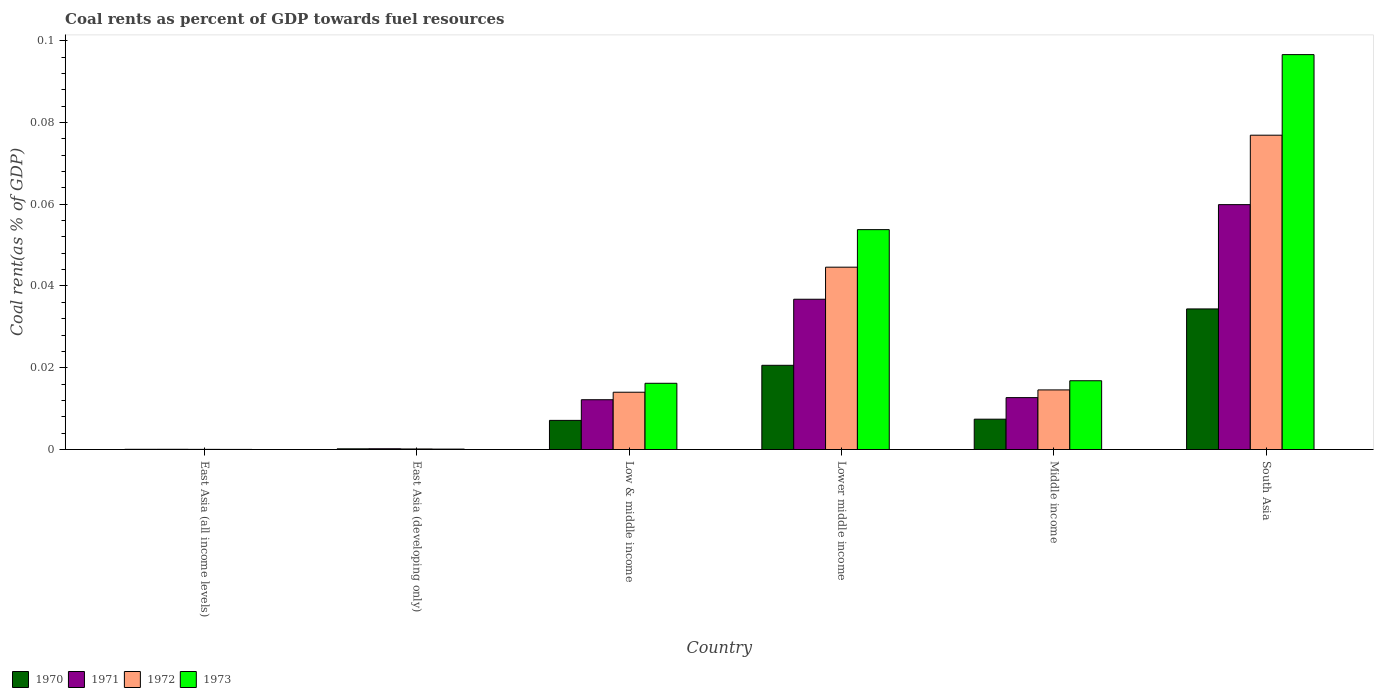How many groups of bars are there?
Provide a short and direct response. 6. Are the number of bars per tick equal to the number of legend labels?
Ensure brevity in your answer.  Yes. What is the label of the 6th group of bars from the left?
Your response must be concise. South Asia. In how many cases, is the number of bars for a given country not equal to the number of legend labels?
Keep it short and to the point. 0. What is the coal rent in 1973 in East Asia (all income levels)?
Make the answer very short. 2.64171247686014e-5. Across all countries, what is the maximum coal rent in 1971?
Your response must be concise. 0.06. Across all countries, what is the minimum coal rent in 1972?
Provide a succinct answer. 3.67730514806032e-5. In which country was the coal rent in 1972 minimum?
Provide a succinct answer. East Asia (all income levels). What is the total coal rent in 1970 in the graph?
Give a very brief answer. 0.07. What is the difference between the coal rent in 1970 in East Asia (all income levels) and that in Lower middle income?
Make the answer very short. -0.02. What is the difference between the coal rent in 1973 in Low & middle income and the coal rent in 1971 in Middle income?
Provide a short and direct response. 0. What is the average coal rent in 1971 per country?
Ensure brevity in your answer.  0.02. What is the difference between the coal rent of/in 1973 and coal rent of/in 1971 in Lower middle income?
Your answer should be very brief. 0.02. In how many countries, is the coal rent in 1972 greater than 0.08 %?
Give a very brief answer. 0. What is the ratio of the coal rent in 1971 in East Asia (all income levels) to that in Lower middle income?
Offer a terse response. 0. Is the coal rent in 1970 in Middle income less than that in South Asia?
Provide a short and direct response. Yes. What is the difference between the highest and the second highest coal rent in 1972?
Ensure brevity in your answer.  0.03. What is the difference between the highest and the lowest coal rent in 1971?
Ensure brevity in your answer.  0.06. Is the sum of the coal rent in 1973 in East Asia (developing only) and South Asia greater than the maximum coal rent in 1971 across all countries?
Provide a succinct answer. Yes. Are the values on the major ticks of Y-axis written in scientific E-notation?
Offer a terse response. No. Does the graph contain any zero values?
Provide a succinct answer. No. Where does the legend appear in the graph?
Offer a very short reply. Bottom left. How are the legend labels stacked?
Offer a terse response. Horizontal. What is the title of the graph?
Provide a succinct answer. Coal rents as percent of GDP towards fuel resources. Does "2001" appear as one of the legend labels in the graph?
Give a very brief answer. No. What is the label or title of the X-axis?
Your answer should be very brief. Country. What is the label or title of the Y-axis?
Make the answer very short. Coal rent(as % of GDP). What is the Coal rent(as % of GDP) of 1970 in East Asia (all income levels)?
Make the answer very short. 5.1314079013758e-5. What is the Coal rent(as % of GDP) of 1971 in East Asia (all income levels)?
Your answer should be very brief. 5.470114168356261e-5. What is the Coal rent(as % of GDP) of 1972 in East Asia (all income levels)?
Give a very brief answer. 3.67730514806032e-5. What is the Coal rent(as % of GDP) in 1973 in East Asia (all income levels)?
Give a very brief answer. 2.64171247686014e-5. What is the Coal rent(as % of GDP) in 1970 in East Asia (developing only)?
Your answer should be very brief. 0. What is the Coal rent(as % of GDP) of 1971 in East Asia (developing only)?
Offer a terse response. 0. What is the Coal rent(as % of GDP) in 1972 in East Asia (developing only)?
Keep it short and to the point. 0. What is the Coal rent(as % of GDP) of 1973 in East Asia (developing only)?
Your response must be concise. 0. What is the Coal rent(as % of GDP) of 1970 in Low & middle income?
Your response must be concise. 0.01. What is the Coal rent(as % of GDP) in 1971 in Low & middle income?
Offer a terse response. 0.01. What is the Coal rent(as % of GDP) in 1972 in Low & middle income?
Make the answer very short. 0.01. What is the Coal rent(as % of GDP) in 1973 in Low & middle income?
Make the answer very short. 0.02. What is the Coal rent(as % of GDP) of 1970 in Lower middle income?
Offer a very short reply. 0.02. What is the Coal rent(as % of GDP) of 1971 in Lower middle income?
Your response must be concise. 0.04. What is the Coal rent(as % of GDP) in 1972 in Lower middle income?
Make the answer very short. 0.04. What is the Coal rent(as % of GDP) in 1973 in Lower middle income?
Your answer should be very brief. 0.05. What is the Coal rent(as % of GDP) in 1970 in Middle income?
Keep it short and to the point. 0.01. What is the Coal rent(as % of GDP) of 1971 in Middle income?
Your response must be concise. 0.01. What is the Coal rent(as % of GDP) in 1972 in Middle income?
Provide a short and direct response. 0.01. What is the Coal rent(as % of GDP) of 1973 in Middle income?
Provide a short and direct response. 0.02. What is the Coal rent(as % of GDP) in 1970 in South Asia?
Provide a short and direct response. 0.03. What is the Coal rent(as % of GDP) in 1971 in South Asia?
Your response must be concise. 0.06. What is the Coal rent(as % of GDP) of 1972 in South Asia?
Give a very brief answer. 0.08. What is the Coal rent(as % of GDP) of 1973 in South Asia?
Give a very brief answer. 0.1. Across all countries, what is the maximum Coal rent(as % of GDP) of 1970?
Your answer should be compact. 0.03. Across all countries, what is the maximum Coal rent(as % of GDP) in 1971?
Your response must be concise. 0.06. Across all countries, what is the maximum Coal rent(as % of GDP) of 1972?
Offer a very short reply. 0.08. Across all countries, what is the maximum Coal rent(as % of GDP) in 1973?
Provide a short and direct response. 0.1. Across all countries, what is the minimum Coal rent(as % of GDP) in 1970?
Your answer should be compact. 5.1314079013758e-5. Across all countries, what is the minimum Coal rent(as % of GDP) of 1971?
Your answer should be very brief. 5.470114168356261e-5. Across all countries, what is the minimum Coal rent(as % of GDP) in 1972?
Give a very brief answer. 3.67730514806032e-5. Across all countries, what is the minimum Coal rent(as % of GDP) in 1973?
Ensure brevity in your answer.  2.64171247686014e-5. What is the total Coal rent(as % of GDP) of 1970 in the graph?
Provide a short and direct response. 0.07. What is the total Coal rent(as % of GDP) of 1971 in the graph?
Offer a very short reply. 0.12. What is the total Coal rent(as % of GDP) of 1972 in the graph?
Offer a very short reply. 0.15. What is the total Coal rent(as % of GDP) in 1973 in the graph?
Offer a very short reply. 0.18. What is the difference between the Coal rent(as % of GDP) of 1970 in East Asia (all income levels) and that in East Asia (developing only)?
Provide a succinct answer. -0. What is the difference between the Coal rent(as % of GDP) of 1971 in East Asia (all income levels) and that in East Asia (developing only)?
Offer a very short reply. -0. What is the difference between the Coal rent(as % of GDP) of 1972 in East Asia (all income levels) and that in East Asia (developing only)?
Offer a very short reply. -0. What is the difference between the Coal rent(as % of GDP) in 1973 in East Asia (all income levels) and that in East Asia (developing only)?
Provide a succinct answer. -0. What is the difference between the Coal rent(as % of GDP) in 1970 in East Asia (all income levels) and that in Low & middle income?
Provide a short and direct response. -0.01. What is the difference between the Coal rent(as % of GDP) in 1971 in East Asia (all income levels) and that in Low & middle income?
Your answer should be compact. -0.01. What is the difference between the Coal rent(as % of GDP) in 1972 in East Asia (all income levels) and that in Low & middle income?
Make the answer very short. -0.01. What is the difference between the Coal rent(as % of GDP) in 1973 in East Asia (all income levels) and that in Low & middle income?
Your answer should be very brief. -0.02. What is the difference between the Coal rent(as % of GDP) in 1970 in East Asia (all income levels) and that in Lower middle income?
Your answer should be compact. -0.02. What is the difference between the Coal rent(as % of GDP) in 1971 in East Asia (all income levels) and that in Lower middle income?
Offer a very short reply. -0.04. What is the difference between the Coal rent(as % of GDP) in 1972 in East Asia (all income levels) and that in Lower middle income?
Keep it short and to the point. -0.04. What is the difference between the Coal rent(as % of GDP) in 1973 in East Asia (all income levels) and that in Lower middle income?
Give a very brief answer. -0.05. What is the difference between the Coal rent(as % of GDP) in 1970 in East Asia (all income levels) and that in Middle income?
Your answer should be compact. -0.01. What is the difference between the Coal rent(as % of GDP) in 1971 in East Asia (all income levels) and that in Middle income?
Offer a very short reply. -0.01. What is the difference between the Coal rent(as % of GDP) of 1972 in East Asia (all income levels) and that in Middle income?
Provide a short and direct response. -0.01. What is the difference between the Coal rent(as % of GDP) in 1973 in East Asia (all income levels) and that in Middle income?
Keep it short and to the point. -0.02. What is the difference between the Coal rent(as % of GDP) in 1970 in East Asia (all income levels) and that in South Asia?
Offer a terse response. -0.03. What is the difference between the Coal rent(as % of GDP) in 1971 in East Asia (all income levels) and that in South Asia?
Your answer should be compact. -0.06. What is the difference between the Coal rent(as % of GDP) of 1972 in East Asia (all income levels) and that in South Asia?
Offer a terse response. -0.08. What is the difference between the Coal rent(as % of GDP) in 1973 in East Asia (all income levels) and that in South Asia?
Provide a short and direct response. -0.1. What is the difference between the Coal rent(as % of GDP) of 1970 in East Asia (developing only) and that in Low & middle income?
Offer a terse response. -0.01. What is the difference between the Coal rent(as % of GDP) in 1971 in East Asia (developing only) and that in Low & middle income?
Ensure brevity in your answer.  -0.01. What is the difference between the Coal rent(as % of GDP) in 1972 in East Asia (developing only) and that in Low & middle income?
Provide a short and direct response. -0.01. What is the difference between the Coal rent(as % of GDP) of 1973 in East Asia (developing only) and that in Low & middle income?
Offer a very short reply. -0.02. What is the difference between the Coal rent(as % of GDP) in 1970 in East Asia (developing only) and that in Lower middle income?
Your answer should be very brief. -0.02. What is the difference between the Coal rent(as % of GDP) of 1971 in East Asia (developing only) and that in Lower middle income?
Your answer should be compact. -0.04. What is the difference between the Coal rent(as % of GDP) in 1972 in East Asia (developing only) and that in Lower middle income?
Your response must be concise. -0.04. What is the difference between the Coal rent(as % of GDP) of 1973 in East Asia (developing only) and that in Lower middle income?
Offer a terse response. -0.05. What is the difference between the Coal rent(as % of GDP) of 1970 in East Asia (developing only) and that in Middle income?
Give a very brief answer. -0.01. What is the difference between the Coal rent(as % of GDP) of 1971 in East Asia (developing only) and that in Middle income?
Give a very brief answer. -0.01. What is the difference between the Coal rent(as % of GDP) in 1972 in East Asia (developing only) and that in Middle income?
Keep it short and to the point. -0.01. What is the difference between the Coal rent(as % of GDP) in 1973 in East Asia (developing only) and that in Middle income?
Make the answer very short. -0.02. What is the difference between the Coal rent(as % of GDP) of 1970 in East Asia (developing only) and that in South Asia?
Provide a short and direct response. -0.03. What is the difference between the Coal rent(as % of GDP) of 1971 in East Asia (developing only) and that in South Asia?
Offer a terse response. -0.06. What is the difference between the Coal rent(as % of GDP) in 1972 in East Asia (developing only) and that in South Asia?
Offer a terse response. -0.08. What is the difference between the Coal rent(as % of GDP) in 1973 in East Asia (developing only) and that in South Asia?
Offer a very short reply. -0.1. What is the difference between the Coal rent(as % of GDP) in 1970 in Low & middle income and that in Lower middle income?
Provide a short and direct response. -0.01. What is the difference between the Coal rent(as % of GDP) in 1971 in Low & middle income and that in Lower middle income?
Make the answer very short. -0.02. What is the difference between the Coal rent(as % of GDP) in 1972 in Low & middle income and that in Lower middle income?
Make the answer very short. -0.03. What is the difference between the Coal rent(as % of GDP) of 1973 in Low & middle income and that in Lower middle income?
Provide a short and direct response. -0.04. What is the difference between the Coal rent(as % of GDP) of 1970 in Low & middle income and that in Middle income?
Make the answer very short. -0. What is the difference between the Coal rent(as % of GDP) in 1971 in Low & middle income and that in Middle income?
Give a very brief answer. -0. What is the difference between the Coal rent(as % of GDP) of 1972 in Low & middle income and that in Middle income?
Your response must be concise. -0. What is the difference between the Coal rent(as % of GDP) of 1973 in Low & middle income and that in Middle income?
Offer a very short reply. -0. What is the difference between the Coal rent(as % of GDP) of 1970 in Low & middle income and that in South Asia?
Ensure brevity in your answer.  -0.03. What is the difference between the Coal rent(as % of GDP) of 1971 in Low & middle income and that in South Asia?
Give a very brief answer. -0.05. What is the difference between the Coal rent(as % of GDP) in 1972 in Low & middle income and that in South Asia?
Provide a succinct answer. -0.06. What is the difference between the Coal rent(as % of GDP) of 1973 in Low & middle income and that in South Asia?
Keep it short and to the point. -0.08. What is the difference between the Coal rent(as % of GDP) of 1970 in Lower middle income and that in Middle income?
Give a very brief answer. 0.01. What is the difference between the Coal rent(as % of GDP) of 1971 in Lower middle income and that in Middle income?
Make the answer very short. 0.02. What is the difference between the Coal rent(as % of GDP) of 1973 in Lower middle income and that in Middle income?
Your response must be concise. 0.04. What is the difference between the Coal rent(as % of GDP) of 1970 in Lower middle income and that in South Asia?
Your response must be concise. -0.01. What is the difference between the Coal rent(as % of GDP) in 1971 in Lower middle income and that in South Asia?
Offer a terse response. -0.02. What is the difference between the Coal rent(as % of GDP) of 1972 in Lower middle income and that in South Asia?
Give a very brief answer. -0.03. What is the difference between the Coal rent(as % of GDP) of 1973 in Lower middle income and that in South Asia?
Your answer should be compact. -0.04. What is the difference between the Coal rent(as % of GDP) in 1970 in Middle income and that in South Asia?
Offer a very short reply. -0.03. What is the difference between the Coal rent(as % of GDP) of 1971 in Middle income and that in South Asia?
Your answer should be very brief. -0.05. What is the difference between the Coal rent(as % of GDP) of 1972 in Middle income and that in South Asia?
Keep it short and to the point. -0.06. What is the difference between the Coal rent(as % of GDP) in 1973 in Middle income and that in South Asia?
Provide a short and direct response. -0.08. What is the difference between the Coal rent(as % of GDP) of 1970 in East Asia (all income levels) and the Coal rent(as % of GDP) of 1971 in East Asia (developing only)?
Your answer should be compact. -0. What is the difference between the Coal rent(as % of GDP) of 1970 in East Asia (all income levels) and the Coal rent(as % of GDP) of 1972 in East Asia (developing only)?
Give a very brief answer. -0. What is the difference between the Coal rent(as % of GDP) in 1970 in East Asia (all income levels) and the Coal rent(as % of GDP) in 1973 in East Asia (developing only)?
Your answer should be very brief. -0. What is the difference between the Coal rent(as % of GDP) in 1971 in East Asia (all income levels) and the Coal rent(as % of GDP) in 1972 in East Asia (developing only)?
Your answer should be compact. -0. What is the difference between the Coal rent(as % of GDP) in 1971 in East Asia (all income levels) and the Coal rent(as % of GDP) in 1973 in East Asia (developing only)?
Your answer should be compact. -0. What is the difference between the Coal rent(as % of GDP) of 1972 in East Asia (all income levels) and the Coal rent(as % of GDP) of 1973 in East Asia (developing only)?
Your answer should be compact. -0. What is the difference between the Coal rent(as % of GDP) of 1970 in East Asia (all income levels) and the Coal rent(as % of GDP) of 1971 in Low & middle income?
Offer a terse response. -0.01. What is the difference between the Coal rent(as % of GDP) of 1970 in East Asia (all income levels) and the Coal rent(as % of GDP) of 1972 in Low & middle income?
Keep it short and to the point. -0.01. What is the difference between the Coal rent(as % of GDP) in 1970 in East Asia (all income levels) and the Coal rent(as % of GDP) in 1973 in Low & middle income?
Give a very brief answer. -0.02. What is the difference between the Coal rent(as % of GDP) in 1971 in East Asia (all income levels) and the Coal rent(as % of GDP) in 1972 in Low & middle income?
Your answer should be compact. -0.01. What is the difference between the Coal rent(as % of GDP) in 1971 in East Asia (all income levels) and the Coal rent(as % of GDP) in 1973 in Low & middle income?
Offer a terse response. -0.02. What is the difference between the Coal rent(as % of GDP) in 1972 in East Asia (all income levels) and the Coal rent(as % of GDP) in 1973 in Low & middle income?
Make the answer very short. -0.02. What is the difference between the Coal rent(as % of GDP) of 1970 in East Asia (all income levels) and the Coal rent(as % of GDP) of 1971 in Lower middle income?
Give a very brief answer. -0.04. What is the difference between the Coal rent(as % of GDP) in 1970 in East Asia (all income levels) and the Coal rent(as % of GDP) in 1972 in Lower middle income?
Your answer should be compact. -0.04. What is the difference between the Coal rent(as % of GDP) in 1970 in East Asia (all income levels) and the Coal rent(as % of GDP) in 1973 in Lower middle income?
Ensure brevity in your answer.  -0.05. What is the difference between the Coal rent(as % of GDP) in 1971 in East Asia (all income levels) and the Coal rent(as % of GDP) in 1972 in Lower middle income?
Give a very brief answer. -0.04. What is the difference between the Coal rent(as % of GDP) in 1971 in East Asia (all income levels) and the Coal rent(as % of GDP) in 1973 in Lower middle income?
Offer a terse response. -0.05. What is the difference between the Coal rent(as % of GDP) of 1972 in East Asia (all income levels) and the Coal rent(as % of GDP) of 1973 in Lower middle income?
Your answer should be very brief. -0.05. What is the difference between the Coal rent(as % of GDP) of 1970 in East Asia (all income levels) and the Coal rent(as % of GDP) of 1971 in Middle income?
Your answer should be compact. -0.01. What is the difference between the Coal rent(as % of GDP) in 1970 in East Asia (all income levels) and the Coal rent(as % of GDP) in 1972 in Middle income?
Give a very brief answer. -0.01. What is the difference between the Coal rent(as % of GDP) in 1970 in East Asia (all income levels) and the Coal rent(as % of GDP) in 1973 in Middle income?
Your answer should be very brief. -0.02. What is the difference between the Coal rent(as % of GDP) in 1971 in East Asia (all income levels) and the Coal rent(as % of GDP) in 1972 in Middle income?
Ensure brevity in your answer.  -0.01. What is the difference between the Coal rent(as % of GDP) of 1971 in East Asia (all income levels) and the Coal rent(as % of GDP) of 1973 in Middle income?
Offer a very short reply. -0.02. What is the difference between the Coal rent(as % of GDP) of 1972 in East Asia (all income levels) and the Coal rent(as % of GDP) of 1973 in Middle income?
Offer a terse response. -0.02. What is the difference between the Coal rent(as % of GDP) in 1970 in East Asia (all income levels) and the Coal rent(as % of GDP) in 1971 in South Asia?
Your response must be concise. -0.06. What is the difference between the Coal rent(as % of GDP) of 1970 in East Asia (all income levels) and the Coal rent(as % of GDP) of 1972 in South Asia?
Your answer should be compact. -0.08. What is the difference between the Coal rent(as % of GDP) of 1970 in East Asia (all income levels) and the Coal rent(as % of GDP) of 1973 in South Asia?
Your answer should be compact. -0.1. What is the difference between the Coal rent(as % of GDP) in 1971 in East Asia (all income levels) and the Coal rent(as % of GDP) in 1972 in South Asia?
Give a very brief answer. -0.08. What is the difference between the Coal rent(as % of GDP) of 1971 in East Asia (all income levels) and the Coal rent(as % of GDP) of 1973 in South Asia?
Provide a succinct answer. -0.1. What is the difference between the Coal rent(as % of GDP) of 1972 in East Asia (all income levels) and the Coal rent(as % of GDP) of 1973 in South Asia?
Provide a short and direct response. -0.1. What is the difference between the Coal rent(as % of GDP) in 1970 in East Asia (developing only) and the Coal rent(as % of GDP) in 1971 in Low & middle income?
Provide a short and direct response. -0.01. What is the difference between the Coal rent(as % of GDP) of 1970 in East Asia (developing only) and the Coal rent(as % of GDP) of 1972 in Low & middle income?
Offer a very short reply. -0.01. What is the difference between the Coal rent(as % of GDP) in 1970 in East Asia (developing only) and the Coal rent(as % of GDP) in 1973 in Low & middle income?
Keep it short and to the point. -0.02. What is the difference between the Coal rent(as % of GDP) in 1971 in East Asia (developing only) and the Coal rent(as % of GDP) in 1972 in Low & middle income?
Your answer should be very brief. -0.01. What is the difference between the Coal rent(as % of GDP) of 1971 in East Asia (developing only) and the Coal rent(as % of GDP) of 1973 in Low & middle income?
Ensure brevity in your answer.  -0.02. What is the difference between the Coal rent(as % of GDP) of 1972 in East Asia (developing only) and the Coal rent(as % of GDP) of 1973 in Low & middle income?
Make the answer very short. -0.02. What is the difference between the Coal rent(as % of GDP) of 1970 in East Asia (developing only) and the Coal rent(as % of GDP) of 1971 in Lower middle income?
Provide a succinct answer. -0.04. What is the difference between the Coal rent(as % of GDP) of 1970 in East Asia (developing only) and the Coal rent(as % of GDP) of 1972 in Lower middle income?
Offer a terse response. -0.04. What is the difference between the Coal rent(as % of GDP) of 1970 in East Asia (developing only) and the Coal rent(as % of GDP) of 1973 in Lower middle income?
Your response must be concise. -0.05. What is the difference between the Coal rent(as % of GDP) in 1971 in East Asia (developing only) and the Coal rent(as % of GDP) in 1972 in Lower middle income?
Your response must be concise. -0.04. What is the difference between the Coal rent(as % of GDP) in 1971 in East Asia (developing only) and the Coal rent(as % of GDP) in 1973 in Lower middle income?
Provide a short and direct response. -0.05. What is the difference between the Coal rent(as % of GDP) of 1972 in East Asia (developing only) and the Coal rent(as % of GDP) of 1973 in Lower middle income?
Your response must be concise. -0.05. What is the difference between the Coal rent(as % of GDP) in 1970 in East Asia (developing only) and the Coal rent(as % of GDP) in 1971 in Middle income?
Provide a short and direct response. -0.01. What is the difference between the Coal rent(as % of GDP) in 1970 in East Asia (developing only) and the Coal rent(as % of GDP) in 1972 in Middle income?
Provide a succinct answer. -0.01. What is the difference between the Coal rent(as % of GDP) of 1970 in East Asia (developing only) and the Coal rent(as % of GDP) of 1973 in Middle income?
Offer a very short reply. -0.02. What is the difference between the Coal rent(as % of GDP) of 1971 in East Asia (developing only) and the Coal rent(as % of GDP) of 1972 in Middle income?
Offer a terse response. -0.01. What is the difference between the Coal rent(as % of GDP) of 1971 in East Asia (developing only) and the Coal rent(as % of GDP) of 1973 in Middle income?
Provide a short and direct response. -0.02. What is the difference between the Coal rent(as % of GDP) of 1972 in East Asia (developing only) and the Coal rent(as % of GDP) of 1973 in Middle income?
Make the answer very short. -0.02. What is the difference between the Coal rent(as % of GDP) in 1970 in East Asia (developing only) and the Coal rent(as % of GDP) in 1971 in South Asia?
Keep it short and to the point. -0.06. What is the difference between the Coal rent(as % of GDP) of 1970 in East Asia (developing only) and the Coal rent(as % of GDP) of 1972 in South Asia?
Give a very brief answer. -0.08. What is the difference between the Coal rent(as % of GDP) in 1970 in East Asia (developing only) and the Coal rent(as % of GDP) in 1973 in South Asia?
Make the answer very short. -0.1. What is the difference between the Coal rent(as % of GDP) in 1971 in East Asia (developing only) and the Coal rent(as % of GDP) in 1972 in South Asia?
Keep it short and to the point. -0.08. What is the difference between the Coal rent(as % of GDP) of 1971 in East Asia (developing only) and the Coal rent(as % of GDP) of 1973 in South Asia?
Provide a short and direct response. -0.1. What is the difference between the Coal rent(as % of GDP) of 1972 in East Asia (developing only) and the Coal rent(as % of GDP) of 1973 in South Asia?
Your response must be concise. -0.1. What is the difference between the Coal rent(as % of GDP) of 1970 in Low & middle income and the Coal rent(as % of GDP) of 1971 in Lower middle income?
Provide a short and direct response. -0.03. What is the difference between the Coal rent(as % of GDP) in 1970 in Low & middle income and the Coal rent(as % of GDP) in 1972 in Lower middle income?
Offer a terse response. -0.04. What is the difference between the Coal rent(as % of GDP) of 1970 in Low & middle income and the Coal rent(as % of GDP) of 1973 in Lower middle income?
Your answer should be compact. -0.05. What is the difference between the Coal rent(as % of GDP) of 1971 in Low & middle income and the Coal rent(as % of GDP) of 1972 in Lower middle income?
Offer a very short reply. -0.03. What is the difference between the Coal rent(as % of GDP) in 1971 in Low & middle income and the Coal rent(as % of GDP) in 1973 in Lower middle income?
Give a very brief answer. -0.04. What is the difference between the Coal rent(as % of GDP) of 1972 in Low & middle income and the Coal rent(as % of GDP) of 1973 in Lower middle income?
Your answer should be compact. -0.04. What is the difference between the Coal rent(as % of GDP) of 1970 in Low & middle income and the Coal rent(as % of GDP) of 1971 in Middle income?
Make the answer very short. -0.01. What is the difference between the Coal rent(as % of GDP) in 1970 in Low & middle income and the Coal rent(as % of GDP) in 1972 in Middle income?
Make the answer very short. -0.01. What is the difference between the Coal rent(as % of GDP) of 1970 in Low & middle income and the Coal rent(as % of GDP) of 1973 in Middle income?
Make the answer very short. -0.01. What is the difference between the Coal rent(as % of GDP) in 1971 in Low & middle income and the Coal rent(as % of GDP) in 1972 in Middle income?
Your answer should be compact. -0. What is the difference between the Coal rent(as % of GDP) in 1971 in Low & middle income and the Coal rent(as % of GDP) in 1973 in Middle income?
Keep it short and to the point. -0. What is the difference between the Coal rent(as % of GDP) in 1972 in Low & middle income and the Coal rent(as % of GDP) in 1973 in Middle income?
Make the answer very short. -0. What is the difference between the Coal rent(as % of GDP) of 1970 in Low & middle income and the Coal rent(as % of GDP) of 1971 in South Asia?
Offer a very short reply. -0.05. What is the difference between the Coal rent(as % of GDP) in 1970 in Low & middle income and the Coal rent(as % of GDP) in 1972 in South Asia?
Your answer should be compact. -0.07. What is the difference between the Coal rent(as % of GDP) of 1970 in Low & middle income and the Coal rent(as % of GDP) of 1973 in South Asia?
Your answer should be very brief. -0.09. What is the difference between the Coal rent(as % of GDP) in 1971 in Low & middle income and the Coal rent(as % of GDP) in 1972 in South Asia?
Keep it short and to the point. -0.06. What is the difference between the Coal rent(as % of GDP) in 1971 in Low & middle income and the Coal rent(as % of GDP) in 1973 in South Asia?
Keep it short and to the point. -0.08. What is the difference between the Coal rent(as % of GDP) of 1972 in Low & middle income and the Coal rent(as % of GDP) of 1973 in South Asia?
Provide a succinct answer. -0.08. What is the difference between the Coal rent(as % of GDP) in 1970 in Lower middle income and the Coal rent(as % of GDP) in 1971 in Middle income?
Your answer should be compact. 0.01. What is the difference between the Coal rent(as % of GDP) in 1970 in Lower middle income and the Coal rent(as % of GDP) in 1972 in Middle income?
Ensure brevity in your answer.  0.01. What is the difference between the Coal rent(as % of GDP) in 1970 in Lower middle income and the Coal rent(as % of GDP) in 1973 in Middle income?
Your answer should be very brief. 0. What is the difference between the Coal rent(as % of GDP) in 1971 in Lower middle income and the Coal rent(as % of GDP) in 1972 in Middle income?
Make the answer very short. 0.02. What is the difference between the Coal rent(as % of GDP) in 1971 in Lower middle income and the Coal rent(as % of GDP) in 1973 in Middle income?
Make the answer very short. 0.02. What is the difference between the Coal rent(as % of GDP) of 1972 in Lower middle income and the Coal rent(as % of GDP) of 1973 in Middle income?
Your answer should be compact. 0.03. What is the difference between the Coal rent(as % of GDP) in 1970 in Lower middle income and the Coal rent(as % of GDP) in 1971 in South Asia?
Offer a terse response. -0.04. What is the difference between the Coal rent(as % of GDP) in 1970 in Lower middle income and the Coal rent(as % of GDP) in 1972 in South Asia?
Offer a terse response. -0.06. What is the difference between the Coal rent(as % of GDP) in 1970 in Lower middle income and the Coal rent(as % of GDP) in 1973 in South Asia?
Your response must be concise. -0.08. What is the difference between the Coal rent(as % of GDP) in 1971 in Lower middle income and the Coal rent(as % of GDP) in 1972 in South Asia?
Give a very brief answer. -0.04. What is the difference between the Coal rent(as % of GDP) in 1971 in Lower middle income and the Coal rent(as % of GDP) in 1973 in South Asia?
Give a very brief answer. -0.06. What is the difference between the Coal rent(as % of GDP) of 1972 in Lower middle income and the Coal rent(as % of GDP) of 1973 in South Asia?
Offer a very short reply. -0.05. What is the difference between the Coal rent(as % of GDP) of 1970 in Middle income and the Coal rent(as % of GDP) of 1971 in South Asia?
Offer a very short reply. -0.05. What is the difference between the Coal rent(as % of GDP) of 1970 in Middle income and the Coal rent(as % of GDP) of 1972 in South Asia?
Give a very brief answer. -0.07. What is the difference between the Coal rent(as % of GDP) of 1970 in Middle income and the Coal rent(as % of GDP) of 1973 in South Asia?
Make the answer very short. -0.09. What is the difference between the Coal rent(as % of GDP) in 1971 in Middle income and the Coal rent(as % of GDP) in 1972 in South Asia?
Make the answer very short. -0.06. What is the difference between the Coal rent(as % of GDP) in 1971 in Middle income and the Coal rent(as % of GDP) in 1973 in South Asia?
Your answer should be very brief. -0.08. What is the difference between the Coal rent(as % of GDP) in 1972 in Middle income and the Coal rent(as % of GDP) in 1973 in South Asia?
Keep it short and to the point. -0.08. What is the average Coal rent(as % of GDP) of 1970 per country?
Give a very brief answer. 0.01. What is the average Coal rent(as % of GDP) in 1971 per country?
Your answer should be compact. 0.02. What is the average Coal rent(as % of GDP) in 1972 per country?
Provide a succinct answer. 0.03. What is the average Coal rent(as % of GDP) in 1973 per country?
Your answer should be compact. 0.03. What is the difference between the Coal rent(as % of GDP) in 1970 and Coal rent(as % of GDP) in 1971 in East Asia (all income levels)?
Offer a terse response. -0. What is the difference between the Coal rent(as % of GDP) of 1970 and Coal rent(as % of GDP) of 1973 in East Asia (all income levels)?
Provide a succinct answer. 0. What is the difference between the Coal rent(as % of GDP) in 1971 and Coal rent(as % of GDP) in 1973 in East Asia (all income levels)?
Provide a succinct answer. 0. What is the difference between the Coal rent(as % of GDP) in 1970 and Coal rent(as % of GDP) in 1972 in East Asia (developing only)?
Give a very brief answer. 0. What is the difference between the Coal rent(as % of GDP) in 1970 and Coal rent(as % of GDP) in 1973 in East Asia (developing only)?
Keep it short and to the point. 0. What is the difference between the Coal rent(as % of GDP) of 1970 and Coal rent(as % of GDP) of 1971 in Low & middle income?
Offer a very short reply. -0.01. What is the difference between the Coal rent(as % of GDP) in 1970 and Coal rent(as % of GDP) in 1972 in Low & middle income?
Provide a short and direct response. -0.01. What is the difference between the Coal rent(as % of GDP) in 1970 and Coal rent(as % of GDP) in 1973 in Low & middle income?
Ensure brevity in your answer.  -0.01. What is the difference between the Coal rent(as % of GDP) in 1971 and Coal rent(as % of GDP) in 1972 in Low & middle income?
Offer a very short reply. -0. What is the difference between the Coal rent(as % of GDP) of 1971 and Coal rent(as % of GDP) of 1973 in Low & middle income?
Provide a succinct answer. -0. What is the difference between the Coal rent(as % of GDP) of 1972 and Coal rent(as % of GDP) of 1973 in Low & middle income?
Your answer should be very brief. -0. What is the difference between the Coal rent(as % of GDP) in 1970 and Coal rent(as % of GDP) in 1971 in Lower middle income?
Your response must be concise. -0.02. What is the difference between the Coal rent(as % of GDP) in 1970 and Coal rent(as % of GDP) in 1972 in Lower middle income?
Offer a very short reply. -0.02. What is the difference between the Coal rent(as % of GDP) in 1970 and Coal rent(as % of GDP) in 1973 in Lower middle income?
Keep it short and to the point. -0.03. What is the difference between the Coal rent(as % of GDP) in 1971 and Coal rent(as % of GDP) in 1972 in Lower middle income?
Ensure brevity in your answer.  -0.01. What is the difference between the Coal rent(as % of GDP) of 1971 and Coal rent(as % of GDP) of 1973 in Lower middle income?
Provide a succinct answer. -0.02. What is the difference between the Coal rent(as % of GDP) in 1972 and Coal rent(as % of GDP) in 1973 in Lower middle income?
Give a very brief answer. -0.01. What is the difference between the Coal rent(as % of GDP) of 1970 and Coal rent(as % of GDP) of 1971 in Middle income?
Your response must be concise. -0.01. What is the difference between the Coal rent(as % of GDP) in 1970 and Coal rent(as % of GDP) in 1972 in Middle income?
Offer a very short reply. -0.01. What is the difference between the Coal rent(as % of GDP) of 1970 and Coal rent(as % of GDP) of 1973 in Middle income?
Ensure brevity in your answer.  -0.01. What is the difference between the Coal rent(as % of GDP) in 1971 and Coal rent(as % of GDP) in 1972 in Middle income?
Make the answer very short. -0. What is the difference between the Coal rent(as % of GDP) of 1971 and Coal rent(as % of GDP) of 1973 in Middle income?
Keep it short and to the point. -0. What is the difference between the Coal rent(as % of GDP) of 1972 and Coal rent(as % of GDP) of 1973 in Middle income?
Provide a short and direct response. -0. What is the difference between the Coal rent(as % of GDP) in 1970 and Coal rent(as % of GDP) in 1971 in South Asia?
Give a very brief answer. -0.03. What is the difference between the Coal rent(as % of GDP) in 1970 and Coal rent(as % of GDP) in 1972 in South Asia?
Give a very brief answer. -0.04. What is the difference between the Coal rent(as % of GDP) of 1970 and Coal rent(as % of GDP) of 1973 in South Asia?
Ensure brevity in your answer.  -0.06. What is the difference between the Coal rent(as % of GDP) in 1971 and Coal rent(as % of GDP) in 1972 in South Asia?
Offer a very short reply. -0.02. What is the difference between the Coal rent(as % of GDP) of 1971 and Coal rent(as % of GDP) of 1973 in South Asia?
Your response must be concise. -0.04. What is the difference between the Coal rent(as % of GDP) in 1972 and Coal rent(as % of GDP) in 1973 in South Asia?
Offer a very short reply. -0.02. What is the ratio of the Coal rent(as % of GDP) of 1970 in East Asia (all income levels) to that in East Asia (developing only)?
Offer a terse response. 0.31. What is the ratio of the Coal rent(as % of GDP) in 1971 in East Asia (all income levels) to that in East Asia (developing only)?
Keep it short and to the point. 0.29. What is the ratio of the Coal rent(as % of GDP) of 1972 in East Asia (all income levels) to that in East Asia (developing only)?
Your answer should be compact. 0.27. What is the ratio of the Coal rent(as % of GDP) in 1973 in East Asia (all income levels) to that in East Asia (developing only)?
Provide a short and direct response. 0.26. What is the ratio of the Coal rent(as % of GDP) in 1970 in East Asia (all income levels) to that in Low & middle income?
Ensure brevity in your answer.  0.01. What is the ratio of the Coal rent(as % of GDP) in 1971 in East Asia (all income levels) to that in Low & middle income?
Ensure brevity in your answer.  0. What is the ratio of the Coal rent(as % of GDP) in 1972 in East Asia (all income levels) to that in Low & middle income?
Offer a very short reply. 0. What is the ratio of the Coal rent(as % of GDP) in 1973 in East Asia (all income levels) to that in Low & middle income?
Ensure brevity in your answer.  0. What is the ratio of the Coal rent(as % of GDP) of 1970 in East Asia (all income levels) to that in Lower middle income?
Make the answer very short. 0. What is the ratio of the Coal rent(as % of GDP) of 1971 in East Asia (all income levels) to that in Lower middle income?
Ensure brevity in your answer.  0. What is the ratio of the Coal rent(as % of GDP) of 1972 in East Asia (all income levels) to that in Lower middle income?
Give a very brief answer. 0. What is the ratio of the Coal rent(as % of GDP) of 1970 in East Asia (all income levels) to that in Middle income?
Ensure brevity in your answer.  0.01. What is the ratio of the Coal rent(as % of GDP) of 1971 in East Asia (all income levels) to that in Middle income?
Provide a succinct answer. 0. What is the ratio of the Coal rent(as % of GDP) in 1972 in East Asia (all income levels) to that in Middle income?
Make the answer very short. 0. What is the ratio of the Coal rent(as % of GDP) in 1973 in East Asia (all income levels) to that in Middle income?
Offer a terse response. 0. What is the ratio of the Coal rent(as % of GDP) in 1970 in East Asia (all income levels) to that in South Asia?
Your answer should be compact. 0. What is the ratio of the Coal rent(as % of GDP) in 1971 in East Asia (all income levels) to that in South Asia?
Ensure brevity in your answer.  0. What is the ratio of the Coal rent(as % of GDP) in 1972 in East Asia (all income levels) to that in South Asia?
Provide a short and direct response. 0. What is the ratio of the Coal rent(as % of GDP) in 1973 in East Asia (all income levels) to that in South Asia?
Your answer should be compact. 0. What is the ratio of the Coal rent(as % of GDP) of 1970 in East Asia (developing only) to that in Low & middle income?
Your answer should be compact. 0.02. What is the ratio of the Coal rent(as % of GDP) in 1971 in East Asia (developing only) to that in Low & middle income?
Offer a very short reply. 0.02. What is the ratio of the Coal rent(as % of GDP) in 1972 in East Asia (developing only) to that in Low & middle income?
Make the answer very short. 0.01. What is the ratio of the Coal rent(as % of GDP) of 1973 in East Asia (developing only) to that in Low & middle income?
Keep it short and to the point. 0.01. What is the ratio of the Coal rent(as % of GDP) in 1970 in East Asia (developing only) to that in Lower middle income?
Your response must be concise. 0.01. What is the ratio of the Coal rent(as % of GDP) of 1971 in East Asia (developing only) to that in Lower middle income?
Ensure brevity in your answer.  0.01. What is the ratio of the Coal rent(as % of GDP) in 1972 in East Asia (developing only) to that in Lower middle income?
Your answer should be very brief. 0. What is the ratio of the Coal rent(as % of GDP) in 1973 in East Asia (developing only) to that in Lower middle income?
Your answer should be compact. 0. What is the ratio of the Coal rent(as % of GDP) of 1970 in East Asia (developing only) to that in Middle income?
Your response must be concise. 0.02. What is the ratio of the Coal rent(as % of GDP) of 1971 in East Asia (developing only) to that in Middle income?
Ensure brevity in your answer.  0.01. What is the ratio of the Coal rent(as % of GDP) in 1972 in East Asia (developing only) to that in Middle income?
Your response must be concise. 0.01. What is the ratio of the Coal rent(as % of GDP) of 1973 in East Asia (developing only) to that in Middle income?
Offer a terse response. 0.01. What is the ratio of the Coal rent(as % of GDP) of 1970 in East Asia (developing only) to that in South Asia?
Provide a short and direct response. 0. What is the ratio of the Coal rent(as % of GDP) of 1971 in East Asia (developing only) to that in South Asia?
Your response must be concise. 0. What is the ratio of the Coal rent(as % of GDP) in 1972 in East Asia (developing only) to that in South Asia?
Offer a terse response. 0. What is the ratio of the Coal rent(as % of GDP) of 1973 in East Asia (developing only) to that in South Asia?
Provide a short and direct response. 0. What is the ratio of the Coal rent(as % of GDP) of 1970 in Low & middle income to that in Lower middle income?
Offer a very short reply. 0.35. What is the ratio of the Coal rent(as % of GDP) in 1971 in Low & middle income to that in Lower middle income?
Make the answer very short. 0.33. What is the ratio of the Coal rent(as % of GDP) of 1972 in Low & middle income to that in Lower middle income?
Offer a very short reply. 0.31. What is the ratio of the Coal rent(as % of GDP) of 1973 in Low & middle income to that in Lower middle income?
Ensure brevity in your answer.  0.3. What is the ratio of the Coal rent(as % of GDP) in 1970 in Low & middle income to that in Middle income?
Your answer should be very brief. 0.96. What is the ratio of the Coal rent(as % of GDP) in 1971 in Low & middle income to that in Middle income?
Ensure brevity in your answer.  0.96. What is the ratio of the Coal rent(as % of GDP) of 1972 in Low & middle income to that in Middle income?
Give a very brief answer. 0.96. What is the ratio of the Coal rent(as % of GDP) of 1973 in Low & middle income to that in Middle income?
Ensure brevity in your answer.  0.96. What is the ratio of the Coal rent(as % of GDP) in 1970 in Low & middle income to that in South Asia?
Provide a short and direct response. 0.21. What is the ratio of the Coal rent(as % of GDP) of 1971 in Low & middle income to that in South Asia?
Your response must be concise. 0.2. What is the ratio of the Coal rent(as % of GDP) in 1972 in Low & middle income to that in South Asia?
Your answer should be very brief. 0.18. What is the ratio of the Coal rent(as % of GDP) of 1973 in Low & middle income to that in South Asia?
Offer a very short reply. 0.17. What is the ratio of the Coal rent(as % of GDP) in 1970 in Lower middle income to that in Middle income?
Give a very brief answer. 2.78. What is the ratio of the Coal rent(as % of GDP) in 1971 in Lower middle income to that in Middle income?
Ensure brevity in your answer.  2.9. What is the ratio of the Coal rent(as % of GDP) of 1972 in Lower middle income to that in Middle income?
Ensure brevity in your answer.  3.06. What is the ratio of the Coal rent(as % of GDP) of 1973 in Lower middle income to that in Middle income?
Give a very brief answer. 3.2. What is the ratio of the Coal rent(as % of GDP) in 1970 in Lower middle income to that in South Asia?
Provide a short and direct response. 0.6. What is the ratio of the Coal rent(as % of GDP) of 1971 in Lower middle income to that in South Asia?
Provide a succinct answer. 0.61. What is the ratio of the Coal rent(as % of GDP) in 1972 in Lower middle income to that in South Asia?
Keep it short and to the point. 0.58. What is the ratio of the Coal rent(as % of GDP) in 1973 in Lower middle income to that in South Asia?
Provide a short and direct response. 0.56. What is the ratio of the Coal rent(as % of GDP) of 1970 in Middle income to that in South Asia?
Your answer should be very brief. 0.22. What is the ratio of the Coal rent(as % of GDP) in 1971 in Middle income to that in South Asia?
Your response must be concise. 0.21. What is the ratio of the Coal rent(as % of GDP) in 1972 in Middle income to that in South Asia?
Your answer should be very brief. 0.19. What is the ratio of the Coal rent(as % of GDP) in 1973 in Middle income to that in South Asia?
Offer a very short reply. 0.17. What is the difference between the highest and the second highest Coal rent(as % of GDP) of 1970?
Offer a very short reply. 0.01. What is the difference between the highest and the second highest Coal rent(as % of GDP) in 1971?
Your answer should be very brief. 0.02. What is the difference between the highest and the second highest Coal rent(as % of GDP) in 1972?
Your answer should be very brief. 0.03. What is the difference between the highest and the second highest Coal rent(as % of GDP) in 1973?
Your answer should be compact. 0.04. What is the difference between the highest and the lowest Coal rent(as % of GDP) of 1970?
Offer a terse response. 0.03. What is the difference between the highest and the lowest Coal rent(as % of GDP) in 1971?
Provide a short and direct response. 0.06. What is the difference between the highest and the lowest Coal rent(as % of GDP) in 1972?
Your answer should be very brief. 0.08. What is the difference between the highest and the lowest Coal rent(as % of GDP) in 1973?
Make the answer very short. 0.1. 